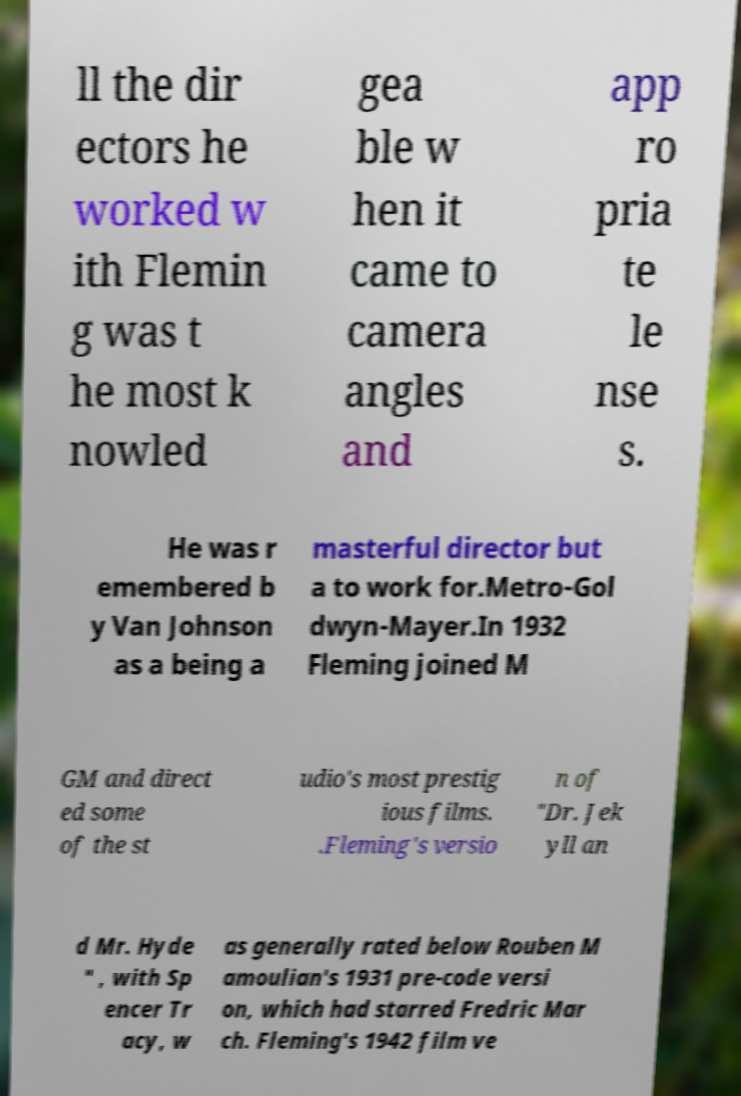Can you accurately transcribe the text from the provided image for me? ll the dir ectors he worked w ith Flemin g was t he most k nowled gea ble w hen it came to camera angles and app ro pria te le nse s. He was r emembered b y Van Johnson as a being a masterful director but a to work for.Metro-Gol dwyn-Mayer.In 1932 Fleming joined M GM and direct ed some of the st udio's most prestig ious films. .Fleming's versio n of "Dr. Jek yll an d Mr. Hyde " , with Sp encer Tr acy, w as generally rated below Rouben M amoulian's 1931 pre-code versi on, which had starred Fredric Mar ch. Fleming's 1942 film ve 